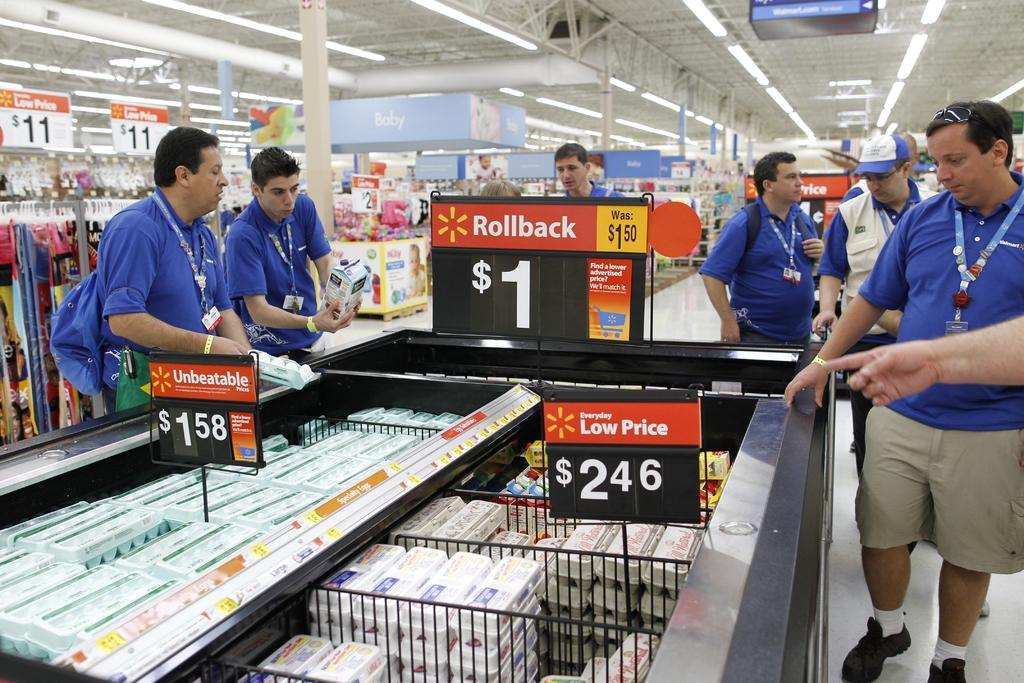<image>
Describe the image concisely. A low price sign shows the price of "$2.46." 